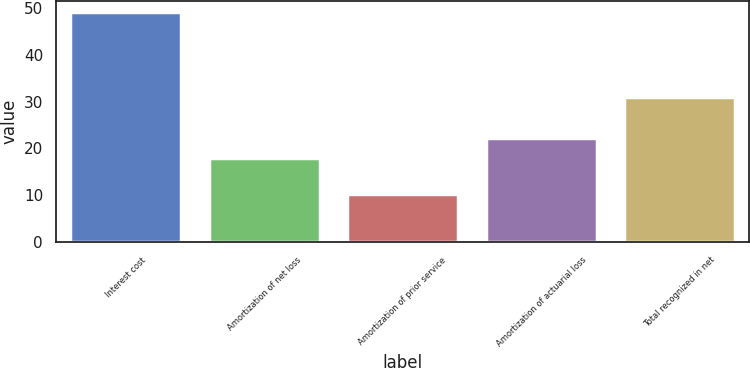Convert chart to OTSL. <chart><loc_0><loc_0><loc_500><loc_500><bar_chart><fcel>Interest cost<fcel>Amortization of net loss<fcel>Amortization of prior service<fcel>Amortization of actuarial loss<fcel>Total recognized in net<nl><fcel>49<fcel>18<fcel>10.3<fcel>22.3<fcel>31<nl></chart> 